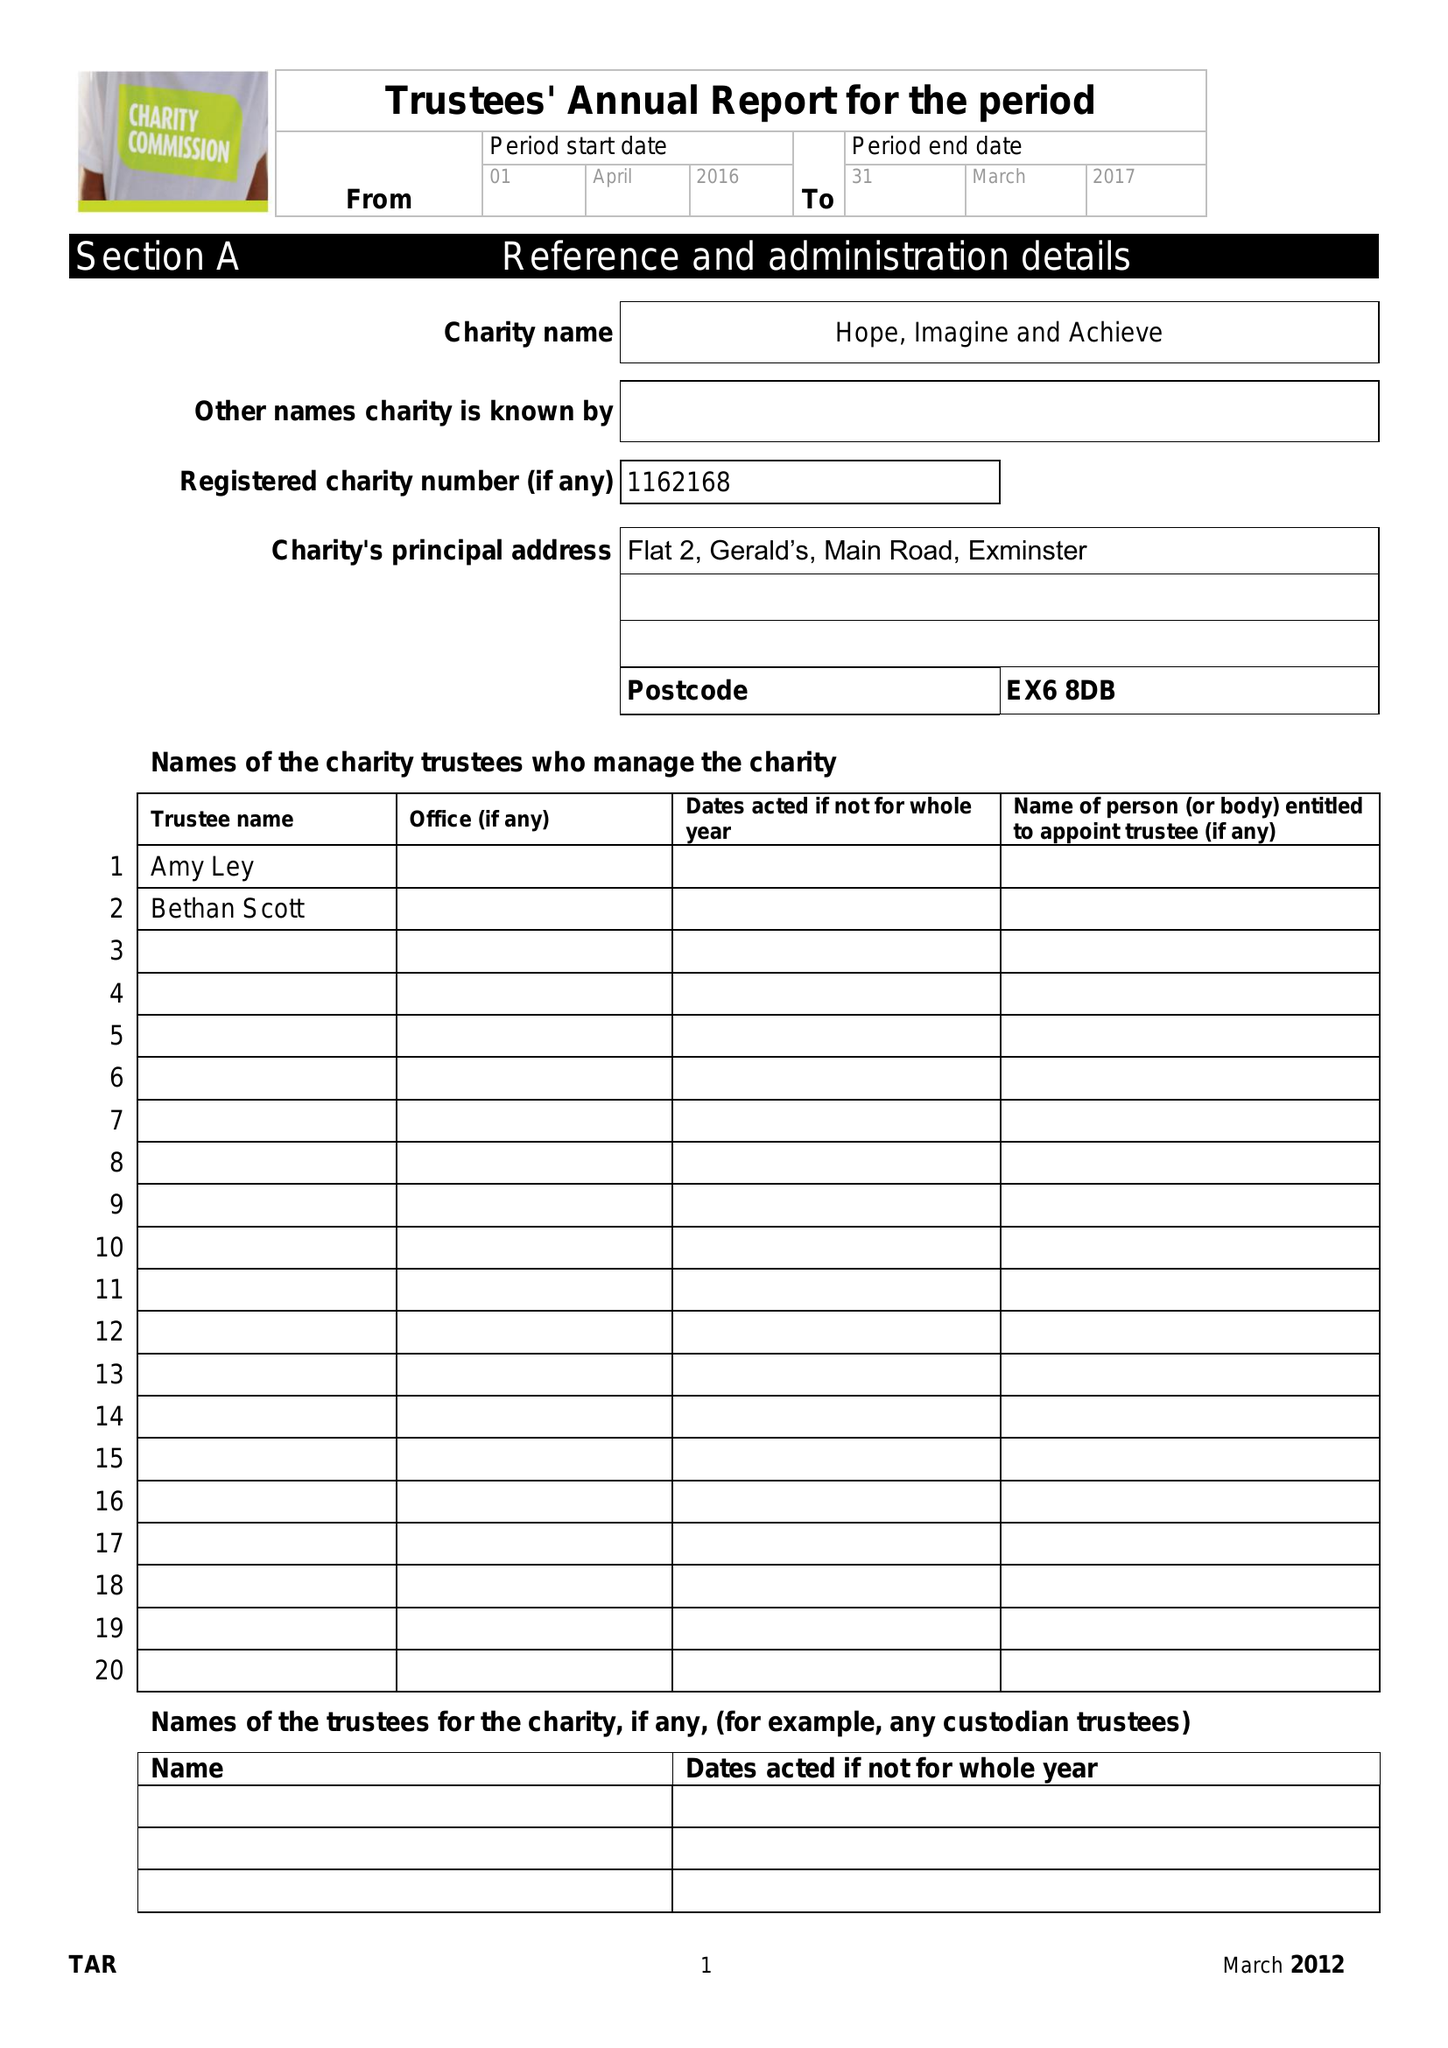What is the value for the address__postcode?
Answer the question using a single word or phrase. EX6 8DB 